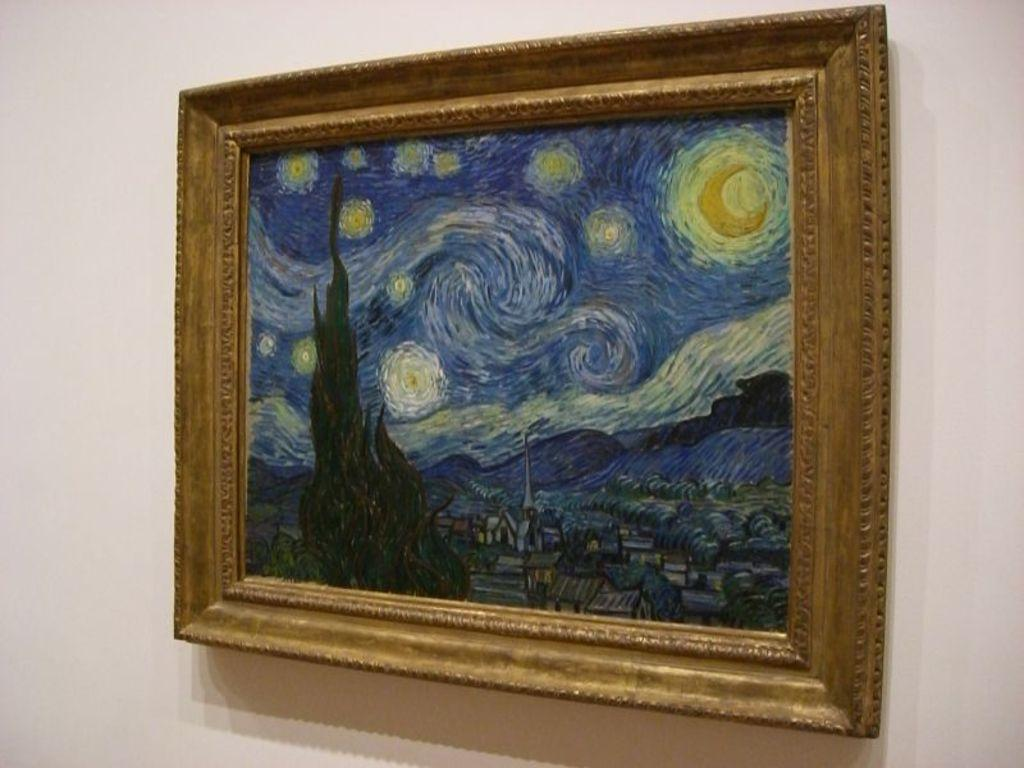What is on the wall in the image? There is a painted frame on the wall in the image. What type of cake is being served in the image? There is no cake present in the image; it only features a painted frame on the wall. 